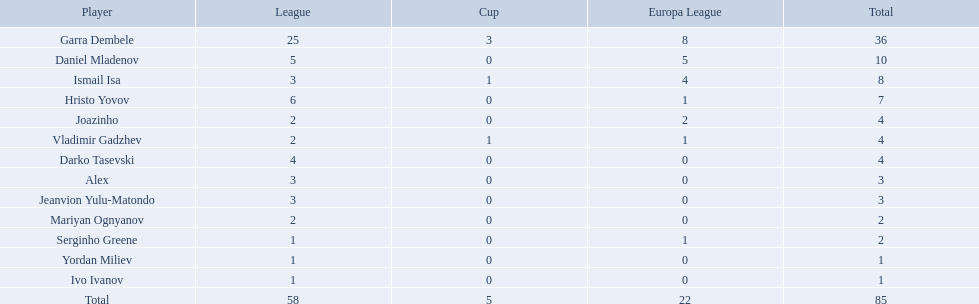Which athletes didn't achieve points in all three contests? Daniel Mladenov, Hristo Yovov, Joazinho, Darko Tasevski, Alex, Jeanvion Yulu-Matondo, Mariyan Ognyanov, Serginho Greene, Yordan Miliev, Ivo Ivanov. Which among them didn't accumulate over 5? Darko Tasevski, Alex, Jeanvion Yulu-Matondo, Mariyan Ognyanov, Serginho Greene, Yordan Miliev, Ivo Ivanov. Which ones garnered over 1 in total? Darko Tasevski, Alex, Jeanvion Yulu-Matondo, Mariyan Ognyanov. Which of these participants had the least league points? Mariyan Ognyanov. Which players failed to score in all three competitions? Daniel Mladenov, Hristo Yovov, Joazinho, Darko Tasevski, Alex, Jeanvion Yulu-Matondo, Mariyan Ognyanov, Serginho Greene, Yordan Miliev, Ivo Ivanov. Among them, who had a total of less than or equal to 5? Darko Tasevski, Alex, Jeanvion Yulu-Matondo, Mariyan Ognyanov, Serginho Greene, Yordan Miliev, Ivo Ivanov. Who had a total greater than 1? Darko Tasevski, Alex, Jeanvion Yulu-Matondo, Mariyan Ognyanov. Lastly, who had the lowest league points? Mariyan Ognyanov. 